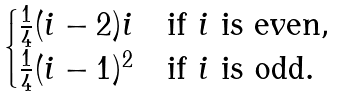Convert formula to latex. <formula><loc_0><loc_0><loc_500><loc_500>\begin{cases} \frac { 1 } { 4 } ( i - 2 ) i & \text {if $i$ is even} , \\ \frac { 1 } { 4 } ( i - 1 ) ^ { 2 } & \text {if $i$ is odd} . \end{cases}</formula> 